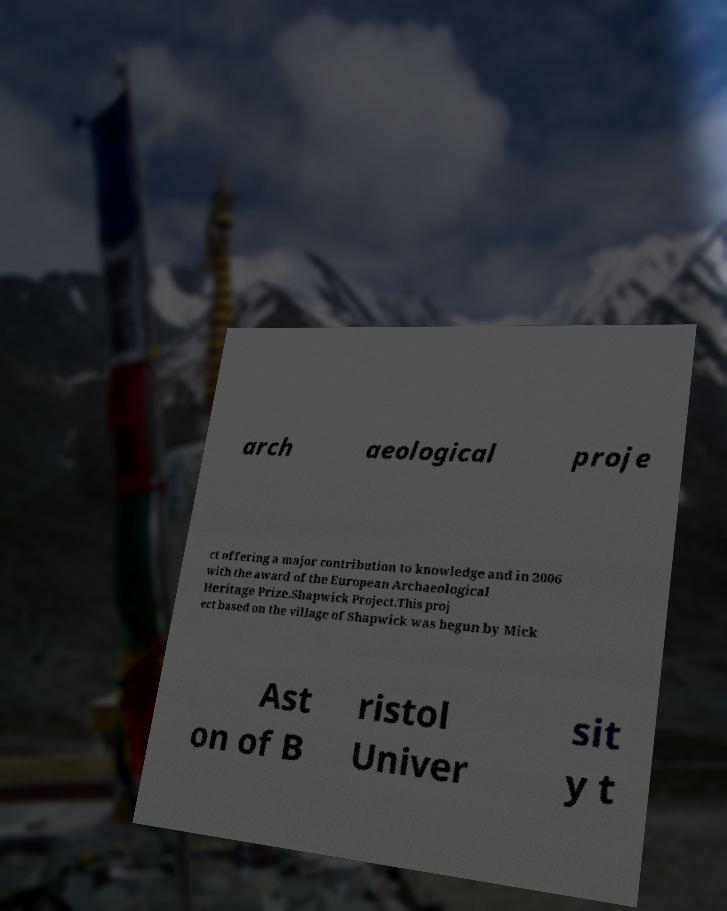There's text embedded in this image that I need extracted. Can you transcribe it verbatim? arch aeological proje ct offering a major contribution to knowledge and in 2006 with the award of the European Archaeological Heritage Prize.Shapwick Project.This proj ect based on the village of Shapwick was begun by Mick Ast on of B ristol Univer sit y t 